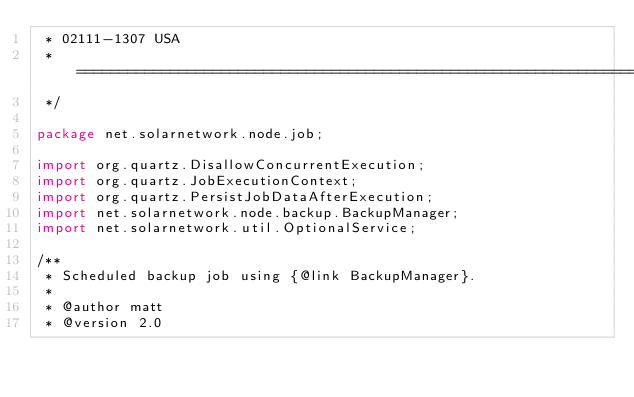Convert code to text. <code><loc_0><loc_0><loc_500><loc_500><_Java_> * 02111-1307 USA
 * ==================================================================
 */

package net.solarnetwork.node.job;

import org.quartz.DisallowConcurrentExecution;
import org.quartz.JobExecutionContext;
import org.quartz.PersistJobDataAfterExecution;
import net.solarnetwork.node.backup.BackupManager;
import net.solarnetwork.util.OptionalService;

/**
 * Scheduled backup job using {@link BackupManager}.
 * 
 * @author matt
 * @version 2.0</code> 